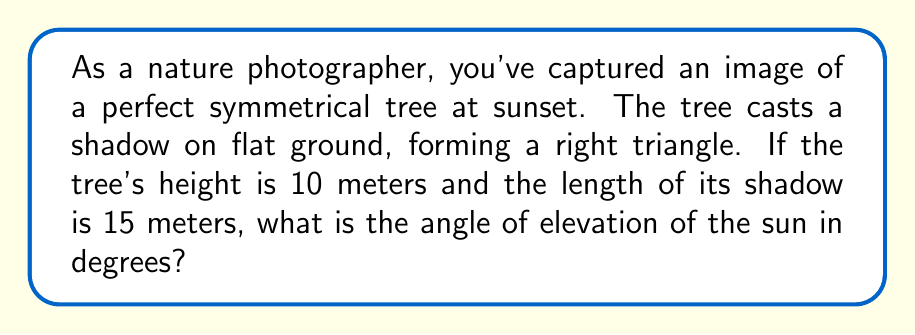Solve this math problem. To solve this problem, we can use trigonometry. Let's approach this step-by-step:

1. Visualize the scenario:
   [asy]
   import geometry;
   
   size(200);
   
   pair A = (0,0), B = (15,0), C = (0,10);
   draw(A--B--C--A);
   
   label("Ground", (7.5,0), S);
   label("Tree", (0,5), W);
   label("Shadow", (7.5,-1), S);
   label("10m", (-0.5,5), W);
   label("15m", (7.5,-2), S);
   label("$\theta$", (1,1), NW);
   
   draw(rightanglemark(A,B,C,2));
   [/asy]

2. We have a right triangle where:
   - The adjacent side (shadow length) is 15 meters
   - The opposite side (tree height) is 10 meters
   - We need to find the angle $\theta$

3. The trigonometric ratio that relates the opposite side to the adjacent side is the tangent:

   $$\tan(\theta) = \frac{\text{opposite}}{\text{adjacent}} = \frac{\text{tree height}}{\text{shadow length}}$$

4. Substituting the values:

   $$\tan(\theta) = \frac{10}{15}$$

5. To find $\theta$, we need to use the inverse tangent (arctangent) function:

   $$\theta = \arctan(\frac{10}{15})$$

6. Calculate this value:

   $$\theta = \arctan(0.6666...) \approx 33.69^\circ$$

7. Round to two decimal places:

   $$\theta \approx 33.69^\circ$$

This angle represents the elevation of the sun above the horizon.
Answer: $33.69^\circ$ 